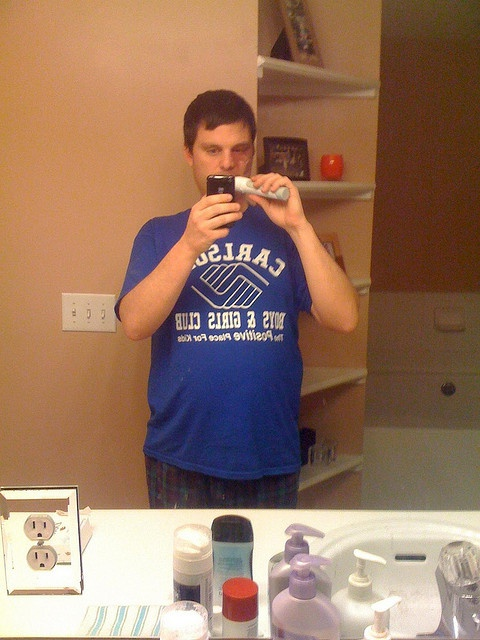Describe the objects in this image and their specific colors. I can see people in olive, navy, salmon, black, and maroon tones, sink in olive, beige, tan, and darkgray tones, bottle in olive, darkgray, pink, and gray tones, bottle in olive, darkgray, gray, and black tones, and bottle in olive, darkgray, gray, and lightgray tones in this image. 